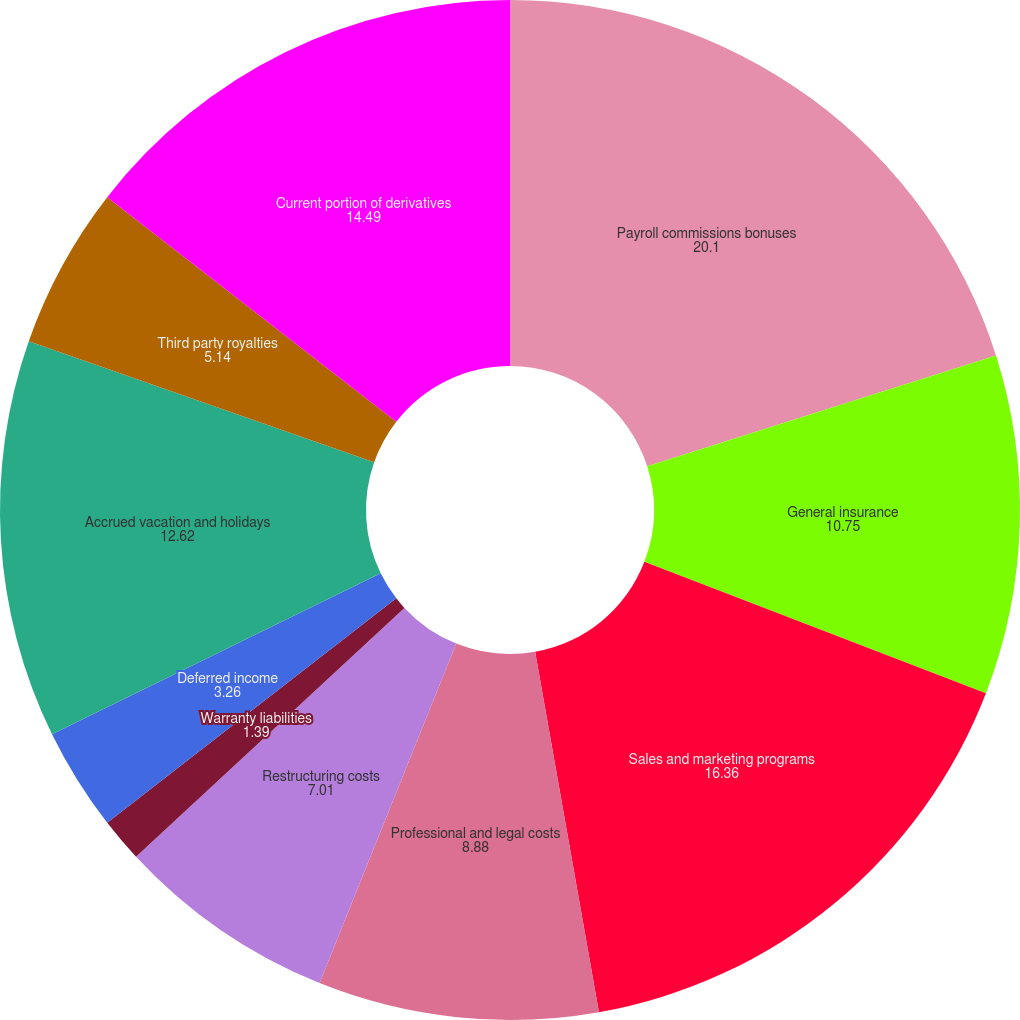<chart> <loc_0><loc_0><loc_500><loc_500><pie_chart><fcel>Payroll commissions bonuses<fcel>General insurance<fcel>Sales and marketing programs<fcel>Professional and legal costs<fcel>Restructuring costs<fcel>Warranty liabilities<fcel>Deferred income<fcel>Accrued vacation and holidays<fcel>Third party royalties<fcel>Current portion of derivatives<nl><fcel>20.1%<fcel>10.75%<fcel>16.36%<fcel>8.88%<fcel>7.01%<fcel>1.39%<fcel>3.26%<fcel>12.62%<fcel>5.14%<fcel>14.49%<nl></chart> 